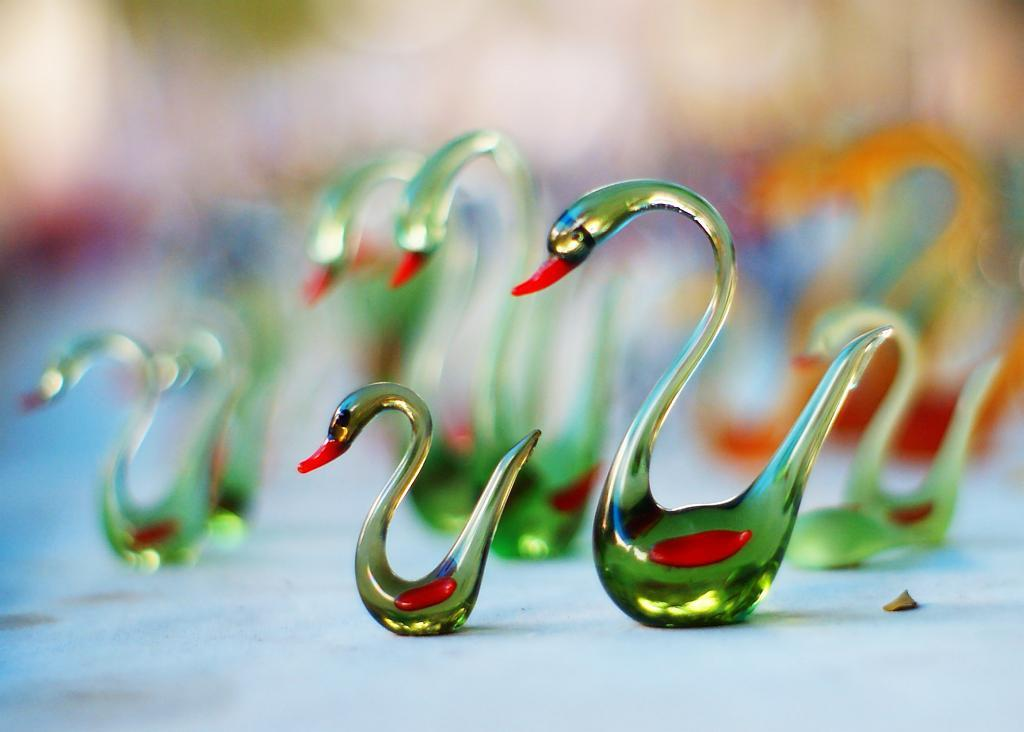What type of sculptures are in the image? There are crystal sculptures in the image. Where are the crystal sculptures located? The crystal sculptures are on a platform. What invention is being used to measure the distance between the crystal sculptures in the image? There is no invention or measurement being depicted in the image; it only shows crystal sculptures on a platform. 